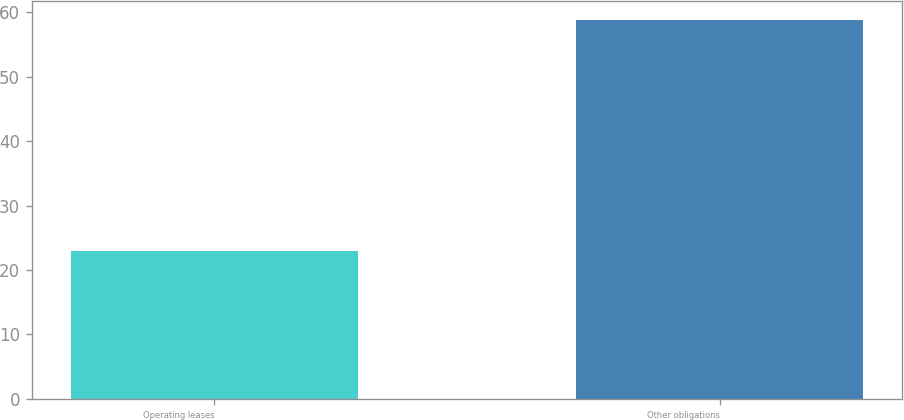Convert chart. <chart><loc_0><loc_0><loc_500><loc_500><bar_chart><fcel>Operating leases<fcel>Other obligations<nl><fcel>23<fcel>58.8<nl></chart> 